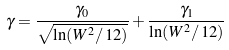Convert formula to latex. <formula><loc_0><loc_0><loc_500><loc_500>\gamma = \frac { \gamma _ { 0 } } { \sqrt { \ln ( W ^ { 2 } / \, 1 2 ) } } + \frac { \gamma _ { 1 } } { \ln ( W ^ { 2 } / \, 1 2 ) }</formula> 